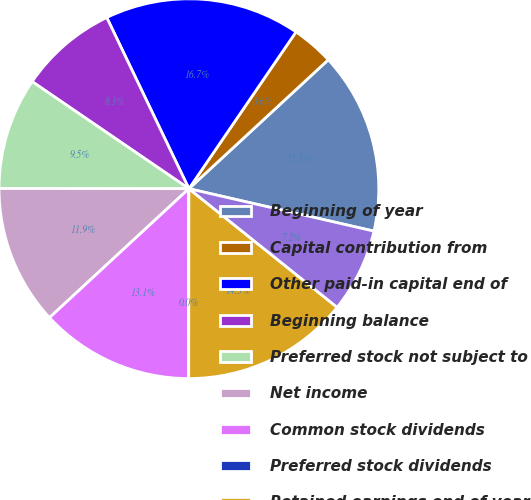Convert chart to OTSL. <chart><loc_0><loc_0><loc_500><loc_500><pie_chart><fcel>Beginning of year<fcel>Capital contribution from<fcel>Other paid-in capital end of<fcel>Beginning balance<fcel>Preferred stock not subject to<fcel>Net income<fcel>Common stock dividends<fcel>Preferred stock dividends<fcel>Retained earnings end of year<fcel>Deferred retirement benefit<nl><fcel>15.47%<fcel>3.58%<fcel>16.66%<fcel>8.34%<fcel>9.52%<fcel>11.9%<fcel>13.09%<fcel>0.01%<fcel>14.28%<fcel>7.15%<nl></chart> 